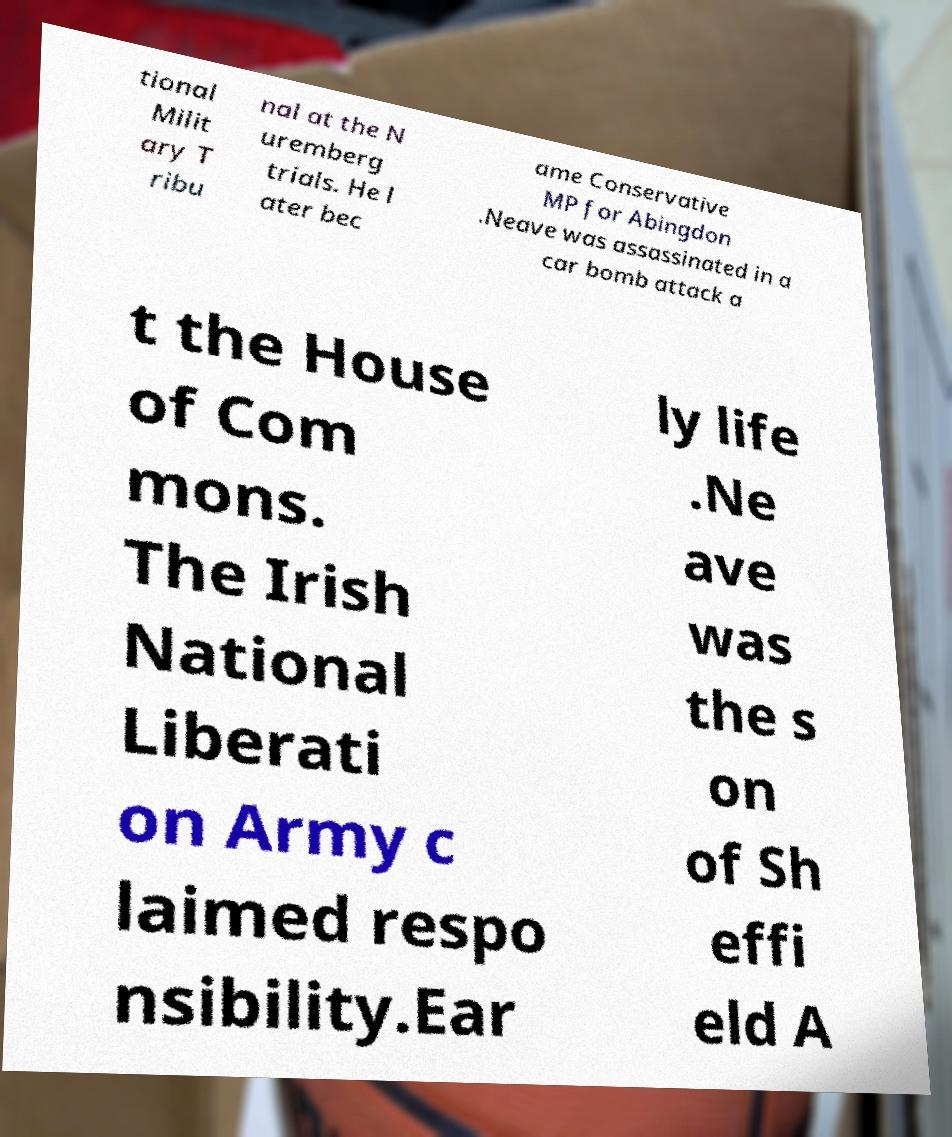There's text embedded in this image that I need extracted. Can you transcribe it verbatim? tional Milit ary T ribu nal at the N uremberg trials. He l ater bec ame Conservative MP for Abingdon .Neave was assassinated in a car bomb attack a t the House of Com mons. The Irish National Liberati on Army c laimed respo nsibility.Ear ly life .Ne ave was the s on of Sh effi eld A 